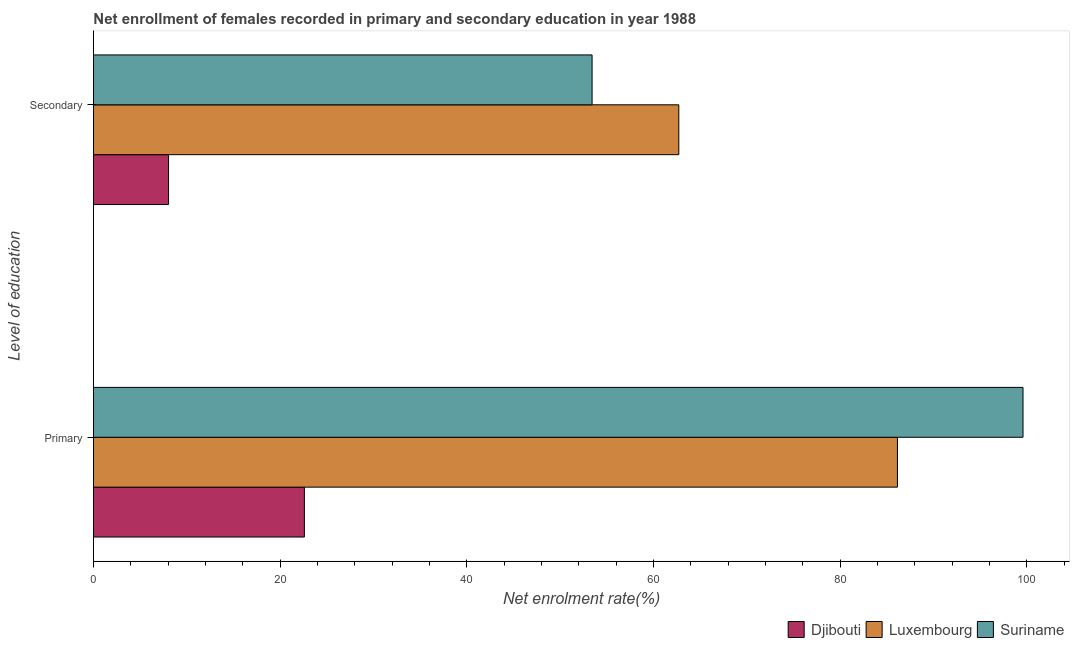Are the number of bars on each tick of the Y-axis equal?
Provide a short and direct response. Yes. How many bars are there on the 2nd tick from the bottom?
Provide a short and direct response. 3. What is the label of the 1st group of bars from the top?
Give a very brief answer. Secondary. What is the enrollment rate in secondary education in Luxembourg?
Your response must be concise. 62.72. Across all countries, what is the maximum enrollment rate in primary education?
Provide a short and direct response. 99.6. Across all countries, what is the minimum enrollment rate in secondary education?
Provide a short and direct response. 8.04. In which country was the enrollment rate in secondary education maximum?
Provide a short and direct response. Luxembourg. In which country was the enrollment rate in primary education minimum?
Provide a succinct answer. Djibouti. What is the total enrollment rate in secondary education in the graph?
Give a very brief answer. 124.19. What is the difference between the enrollment rate in primary education in Djibouti and that in Luxembourg?
Ensure brevity in your answer.  -63.54. What is the difference between the enrollment rate in secondary education in Djibouti and the enrollment rate in primary education in Luxembourg?
Ensure brevity in your answer.  -78.1. What is the average enrollment rate in primary education per country?
Ensure brevity in your answer.  69.45. What is the difference between the enrollment rate in primary education and enrollment rate in secondary education in Suriname?
Make the answer very short. 46.17. In how many countries, is the enrollment rate in secondary education greater than 24 %?
Provide a short and direct response. 2. What is the ratio of the enrollment rate in secondary education in Suriname to that in Luxembourg?
Make the answer very short. 0.85. Is the enrollment rate in primary education in Luxembourg less than that in Djibouti?
Offer a terse response. No. In how many countries, is the enrollment rate in primary education greater than the average enrollment rate in primary education taken over all countries?
Offer a very short reply. 2. What does the 1st bar from the top in Primary represents?
Your answer should be compact. Suriname. What does the 1st bar from the bottom in Secondary represents?
Your response must be concise. Djibouti. How many bars are there?
Provide a succinct answer. 6. How many countries are there in the graph?
Provide a succinct answer. 3. What is the difference between two consecutive major ticks on the X-axis?
Offer a very short reply. 20. Are the values on the major ticks of X-axis written in scientific E-notation?
Provide a short and direct response. No. Does the graph contain any zero values?
Offer a very short reply. No. Where does the legend appear in the graph?
Ensure brevity in your answer.  Bottom right. How many legend labels are there?
Ensure brevity in your answer.  3. What is the title of the graph?
Your answer should be very brief. Net enrollment of females recorded in primary and secondary education in year 1988. What is the label or title of the X-axis?
Give a very brief answer. Net enrolment rate(%). What is the label or title of the Y-axis?
Give a very brief answer. Level of education. What is the Net enrolment rate(%) of Djibouti in Primary?
Provide a succinct answer. 22.6. What is the Net enrolment rate(%) in Luxembourg in Primary?
Keep it short and to the point. 86.14. What is the Net enrolment rate(%) in Suriname in Primary?
Offer a very short reply. 99.6. What is the Net enrolment rate(%) of Djibouti in Secondary?
Provide a succinct answer. 8.04. What is the Net enrolment rate(%) in Luxembourg in Secondary?
Provide a succinct answer. 62.72. What is the Net enrolment rate(%) of Suriname in Secondary?
Offer a very short reply. 53.42. Across all Level of education, what is the maximum Net enrolment rate(%) in Djibouti?
Give a very brief answer. 22.6. Across all Level of education, what is the maximum Net enrolment rate(%) of Luxembourg?
Keep it short and to the point. 86.14. Across all Level of education, what is the maximum Net enrolment rate(%) in Suriname?
Provide a succinct answer. 99.6. Across all Level of education, what is the minimum Net enrolment rate(%) in Djibouti?
Provide a succinct answer. 8.04. Across all Level of education, what is the minimum Net enrolment rate(%) in Luxembourg?
Provide a short and direct response. 62.72. Across all Level of education, what is the minimum Net enrolment rate(%) in Suriname?
Ensure brevity in your answer.  53.42. What is the total Net enrolment rate(%) of Djibouti in the graph?
Give a very brief answer. 30.64. What is the total Net enrolment rate(%) in Luxembourg in the graph?
Offer a very short reply. 148.86. What is the total Net enrolment rate(%) in Suriname in the graph?
Provide a succinct answer. 153.02. What is the difference between the Net enrolment rate(%) in Djibouti in Primary and that in Secondary?
Offer a very short reply. 14.56. What is the difference between the Net enrolment rate(%) of Luxembourg in Primary and that in Secondary?
Offer a very short reply. 23.43. What is the difference between the Net enrolment rate(%) in Suriname in Primary and that in Secondary?
Offer a very short reply. 46.17. What is the difference between the Net enrolment rate(%) of Djibouti in Primary and the Net enrolment rate(%) of Luxembourg in Secondary?
Make the answer very short. -40.12. What is the difference between the Net enrolment rate(%) in Djibouti in Primary and the Net enrolment rate(%) in Suriname in Secondary?
Your answer should be compact. -30.82. What is the difference between the Net enrolment rate(%) in Luxembourg in Primary and the Net enrolment rate(%) in Suriname in Secondary?
Offer a terse response. 32.72. What is the average Net enrolment rate(%) in Djibouti per Level of education?
Ensure brevity in your answer.  15.32. What is the average Net enrolment rate(%) in Luxembourg per Level of education?
Your response must be concise. 74.43. What is the average Net enrolment rate(%) of Suriname per Level of education?
Your response must be concise. 76.51. What is the difference between the Net enrolment rate(%) of Djibouti and Net enrolment rate(%) of Luxembourg in Primary?
Keep it short and to the point. -63.54. What is the difference between the Net enrolment rate(%) in Djibouti and Net enrolment rate(%) in Suriname in Primary?
Give a very brief answer. -77. What is the difference between the Net enrolment rate(%) of Luxembourg and Net enrolment rate(%) of Suriname in Primary?
Ensure brevity in your answer.  -13.45. What is the difference between the Net enrolment rate(%) in Djibouti and Net enrolment rate(%) in Luxembourg in Secondary?
Your answer should be compact. -54.67. What is the difference between the Net enrolment rate(%) in Djibouti and Net enrolment rate(%) in Suriname in Secondary?
Your answer should be very brief. -45.38. What is the difference between the Net enrolment rate(%) of Luxembourg and Net enrolment rate(%) of Suriname in Secondary?
Provide a succinct answer. 9.29. What is the ratio of the Net enrolment rate(%) in Djibouti in Primary to that in Secondary?
Make the answer very short. 2.81. What is the ratio of the Net enrolment rate(%) in Luxembourg in Primary to that in Secondary?
Provide a succinct answer. 1.37. What is the ratio of the Net enrolment rate(%) of Suriname in Primary to that in Secondary?
Provide a short and direct response. 1.86. What is the difference between the highest and the second highest Net enrolment rate(%) of Djibouti?
Your answer should be compact. 14.56. What is the difference between the highest and the second highest Net enrolment rate(%) of Luxembourg?
Ensure brevity in your answer.  23.43. What is the difference between the highest and the second highest Net enrolment rate(%) of Suriname?
Make the answer very short. 46.17. What is the difference between the highest and the lowest Net enrolment rate(%) in Djibouti?
Offer a very short reply. 14.56. What is the difference between the highest and the lowest Net enrolment rate(%) of Luxembourg?
Your answer should be very brief. 23.43. What is the difference between the highest and the lowest Net enrolment rate(%) of Suriname?
Offer a very short reply. 46.17. 